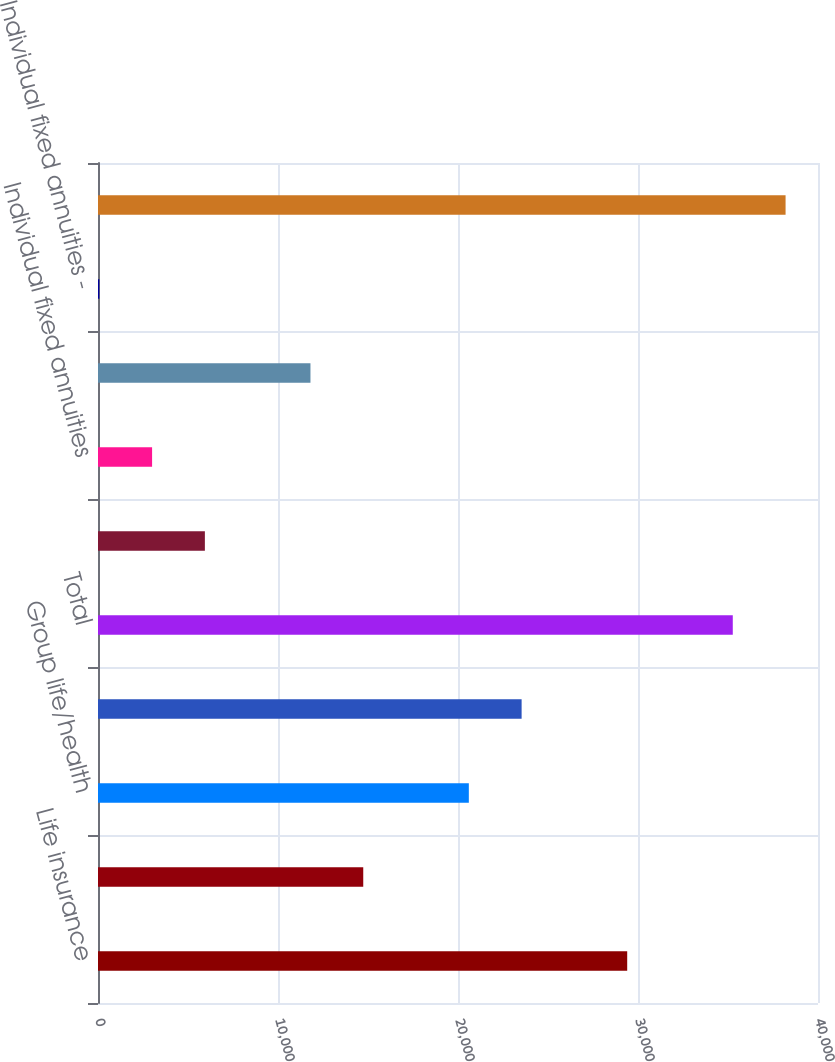<chart> <loc_0><loc_0><loc_500><loc_500><bar_chart><fcel>Life insurance<fcel>Home service<fcel>Group life/health<fcel>Payout annuities (b)<fcel>Total<fcel>Group retirement products<fcel>Individual fixed annuities<fcel>Individual variable annuities<fcel>Individual fixed annuities -<fcel>Total Domestic<nl><fcel>29400<fcel>14736<fcel>20601.6<fcel>23534.4<fcel>35265.6<fcel>5937.6<fcel>3004.8<fcel>11803.2<fcel>72<fcel>38198.4<nl></chart> 